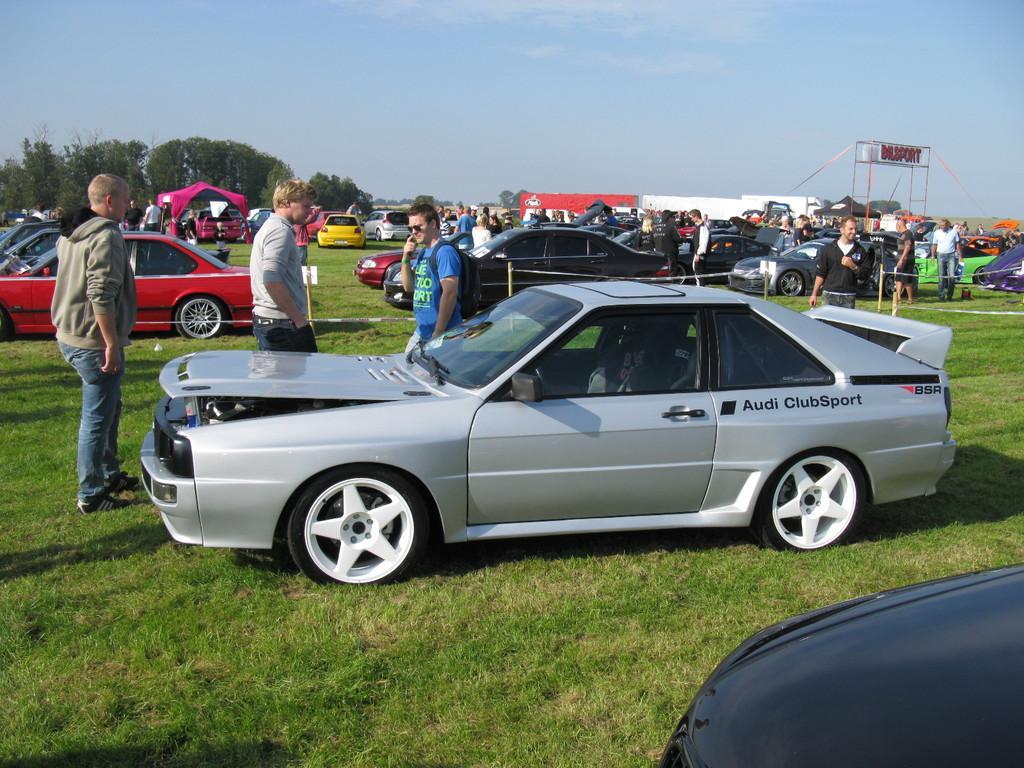Please provide a concise description of this image. In this image, we can see many cars, people, trees, tents and some banners. At the bottom, there is ground. 